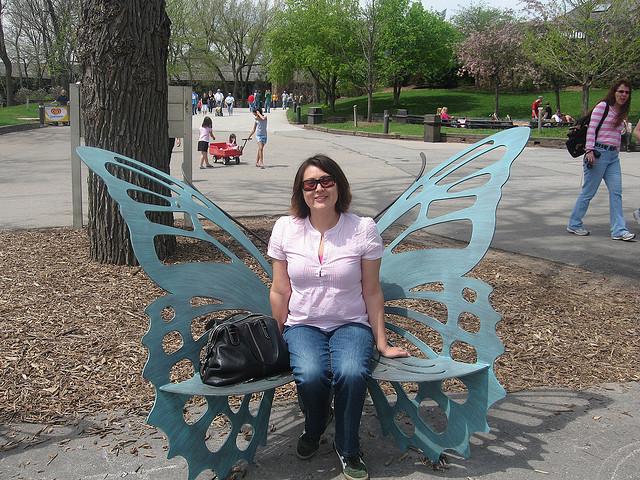Is this woman wearing wings?
Give a very brief answer. No. Is that a typical bench?
Short answer required. No. Is there a lady pulling a dog in a wagon?
Short answer required. No. 